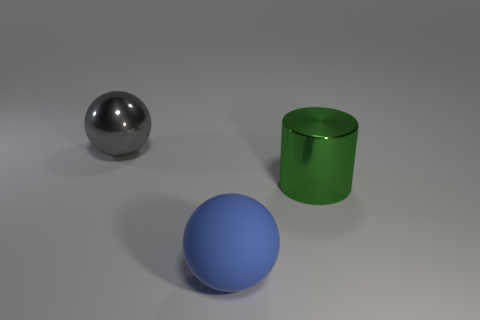Add 1 large cyan cylinders. How many objects exist? 4 Subtract all gray spheres. How many spheres are left? 1 Subtract 1 cylinders. How many cylinders are left? 0 Subtract all cylinders. How many objects are left? 2 Add 3 large blue balls. How many large blue balls are left? 4 Add 3 large balls. How many large balls exist? 5 Subtract 0 yellow cylinders. How many objects are left? 3 Subtract all blue cylinders. Subtract all cyan blocks. How many cylinders are left? 1 Subtract all red blocks. How many yellow balls are left? 0 Subtract all tiny brown rubber cylinders. Subtract all large metallic things. How many objects are left? 1 